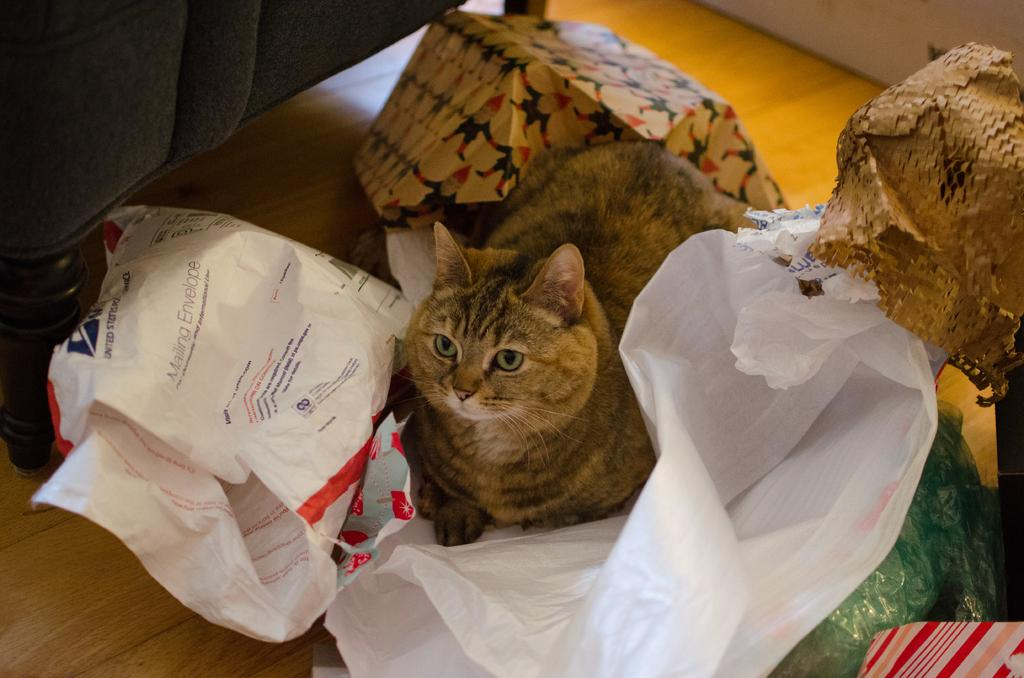What type of material are the covers in the image made of? The covers in the image are made of white-colored plastic. What animal can be seen in the image? There is a brown-colored cat in the image. Can you describe any other items or objects in the image? There are other unspecified stuffs in the image. Where can writing be found in the image? Writing is present in multiple places in the image. How many boys are present in the image? There is no boy present in the image; it features a brown-colored cat and white-colored plastic covers. What type of calculator can be seen in the image? There is no calculator present in the image. 